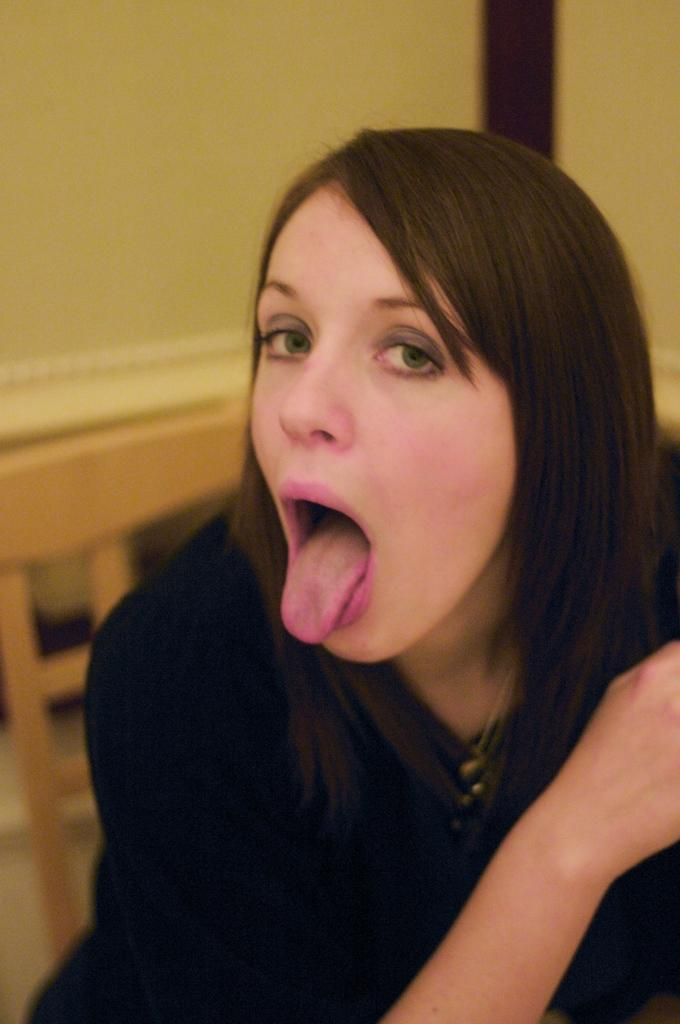Who is the main subject in the image? There is a lady in the image. What is the lady wearing? The lady is wearing a black dress. What can be seen in the background of the image? There is a yellow color wall in the background of the image. How many rocks are visible in the image? There are no rocks visible in the image; it features a lady in a black dress with a yellow wall in the background. 